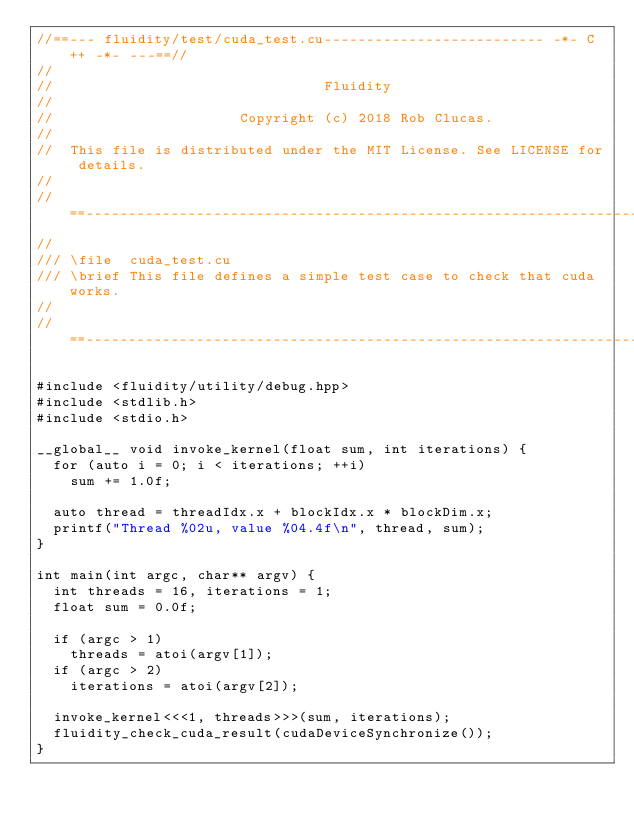<code> <loc_0><loc_0><loc_500><loc_500><_Cuda_>//==--- fluidity/test/cuda_test.cu-------------------------- -*- C++ -*- ---==//
//            
//                                Fluidity
// 
//                      Copyright (c) 2018 Rob Clucas.
//
//  This file is distributed under the MIT License. See LICENSE for details.
//
//==------------------------------------------------------------------------==//
//
/// \file  cuda_test.cu
/// \brief This file defines a simple test case to check that cuda works.
//
//==------------------------------------------------------------------------==//

#include <fluidity/utility/debug.hpp>
#include <stdlib.h>
#include <stdio.h>

__global__ void invoke_kernel(float sum, int iterations) {
  for (auto i = 0; i < iterations; ++i)
    sum += 1.0f;

  auto thread = threadIdx.x + blockIdx.x * blockDim.x;
  printf("Thread %02u, value %04.4f\n", thread, sum);
}

int main(int argc, char** argv) {
  int threads = 16, iterations = 1;
  float sum = 0.0f;

  if (argc > 1)
    threads = atoi(argv[1]);
  if (argc > 2)
    iterations = atoi(argv[2]);

  invoke_kernel<<<1, threads>>>(sum, iterations);
  fluidity_check_cuda_result(cudaDeviceSynchronize());
}
</code> 